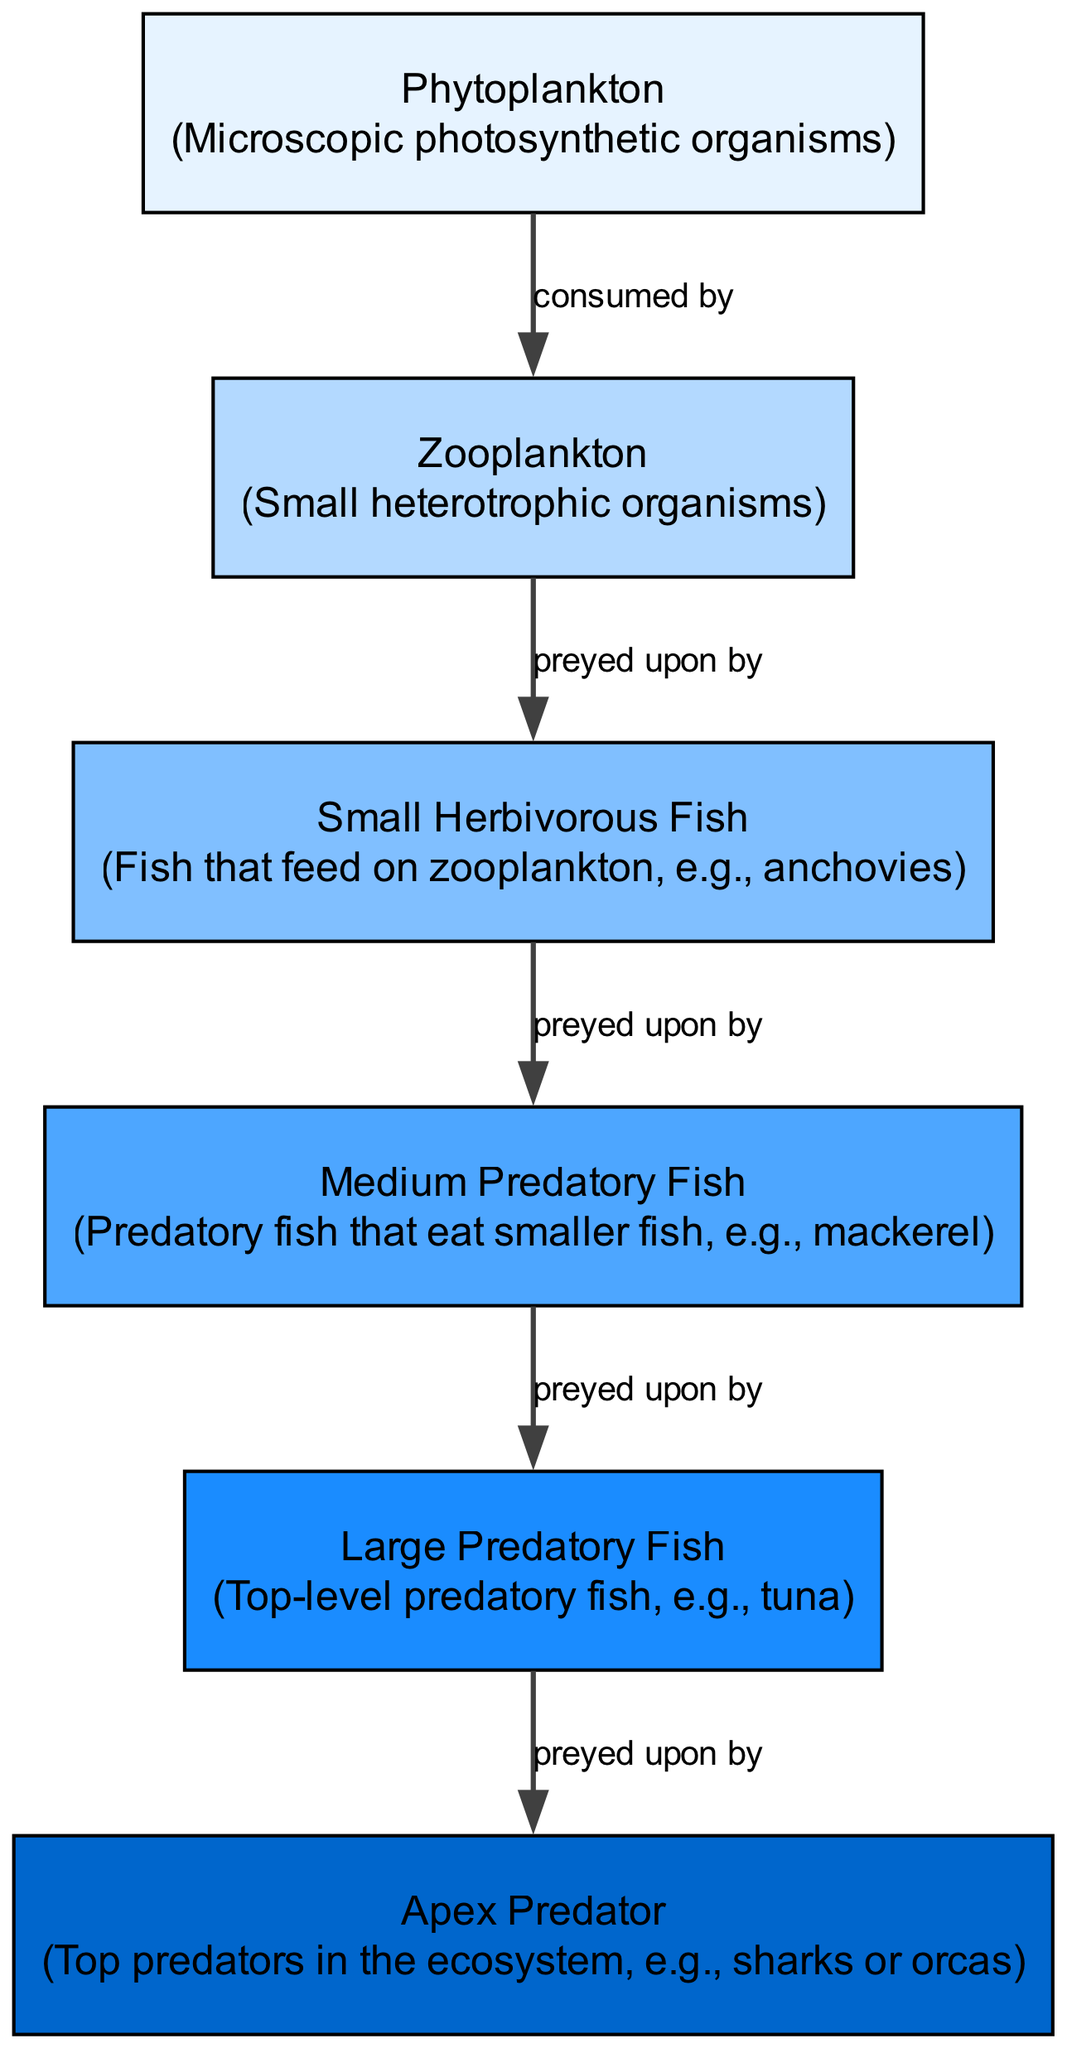What is the first node in the food chain? The first node in the diagram is "Phytoplankton," as it is the starting point of the energy flow in the food chain.
Answer: Phytoplankton How many nodes are there in the diagram? The diagram contains a total of six nodes: phytoplankton, zooplankton, small herbivorous fish, medium predatory fish, large predatory fish, and apex predator.
Answer: 6 What do zooplankton feed on? According to the edges in the diagram, zooplankton are consumed by small herbivorous fish, meaning they feed on zooplankton.
Answer: Small herbivorous fish Which organisms are at the top of the food chain? The apex predator is represented as the top of the food chain in the diagram, as it is preyed upon by large predatory fish.
Answer: Apex Predator How many edges are depicted in the diagram? There are five edges shown that illustrate the relationships between the nodes, indicating the flow of energy from one organism to another.
Answer: 5 Which type of fish is preyed upon by medium predatory fish? The diagram indicates that medium predatory fish prey on small herbivorous fish, establishing the relationship between these two nodes.
Answer: Small herbivorous fish What is the relationship between large predatory fish and apex predator? The edge connecting these nodes shows that large predatory fish are preyed upon by apex predators, indicating their role in the food chain.
Answer: Preyed upon by What is the role of phytoplankton in the ecosystem? Phytoplankton are categorized as primary producers in the diagram as they are the starting point of energy flow through photosynthesis.
Answer: Primary producers Which group directly consumes zooplankton? Small herbivorous fish are directly connected to zooplankton in the diagram, indicating they are the ones that consume zooplankton.
Answer: Small herbivorous fish 